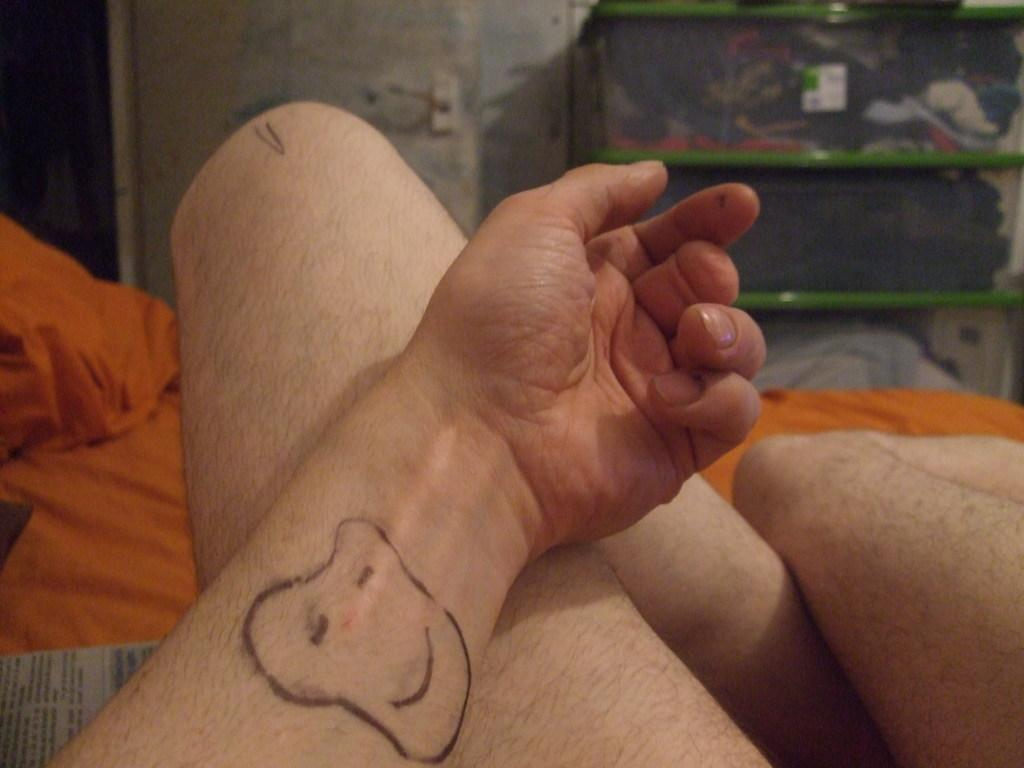Who or what is at the bottom of the image? There is a person at the bottom of the image. What is the person doing or interacting with in the image? The provided facts do not specify what the person is doing or interacting with. What items can be seen in the image besides the person? There are blankets, a newspaper, a box, and a wall visible in the image. What type of whip is being used by the person in the image? There is no whip present in the image. What experience does the person have with the blankets in the image? The provided facts do not specify any experience the person may have with the blankets. 